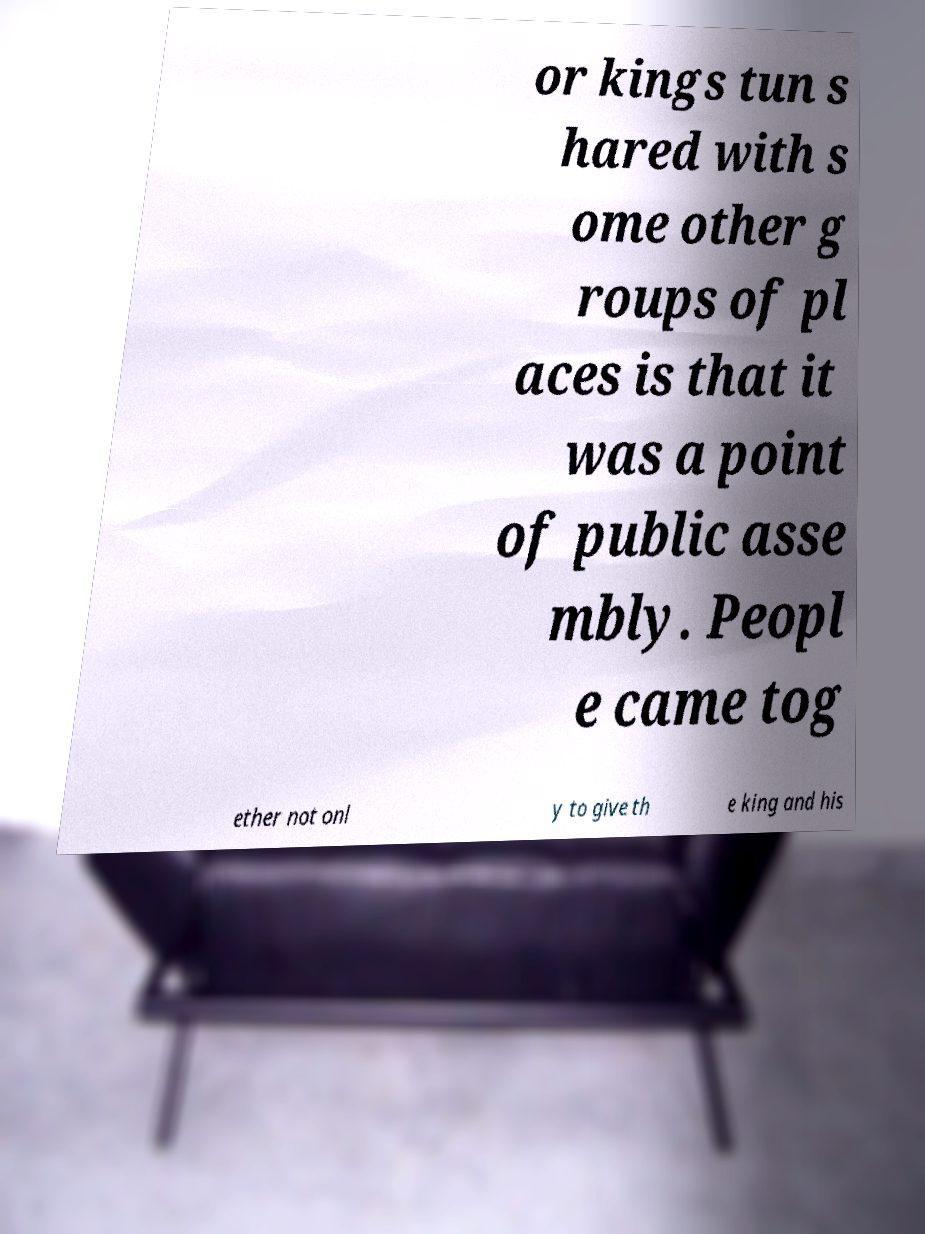Could you extract and type out the text from this image? or kings tun s hared with s ome other g roups of pl aces is that it was a point of public asse mbly. Peopl e came tog ether not onl y to give th e king and his 